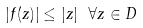<formula> <loc_0><loc_0><loc_500><loc_500>| f ( z ) | \leq | z | \ \forall z \in D</formula> 